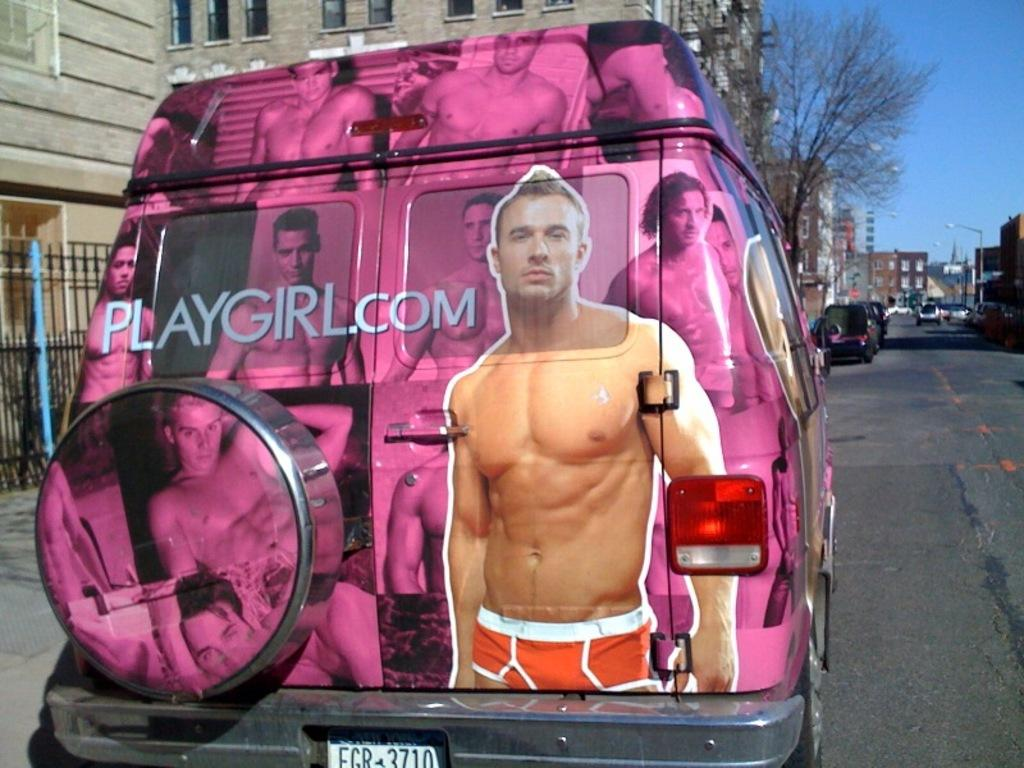What is happening in the image? There are vehicles on a road in the image. Can you describe one of the vehicles in more detail? One of the vehicles has pictures of men and text on it. What can be seen in the distance in the image? There are buildings, light poles, trees, and the sky visible in the background of the image. Where is the lettuce growing in the image? There is no lettuce present in the image. Can you tell me how many parks are visible in the image? There are no parks visible in the image. 